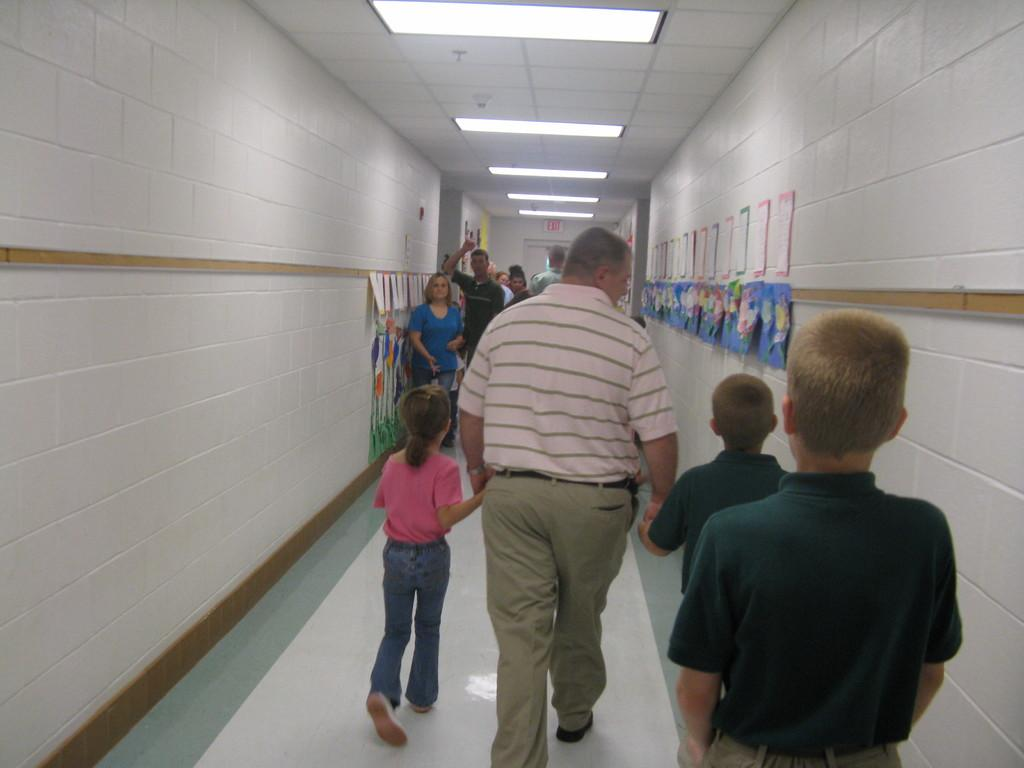Where was the image taken? The image was taken inside a building. What can be seen in the center of the image? There are people walking in the center of the image. What is visible at the top of the image? There are lights at the top of the image. What can be seen on the wall in the background of the image? Papers are placed on the wall in the background of the image. How many apples are hanging from the ceiling in the image? There are no apples present in the image. What type of art is displayed on the wall in the image? The provided facts do not mention any art displayed on the wall; only papers are mentioned. 